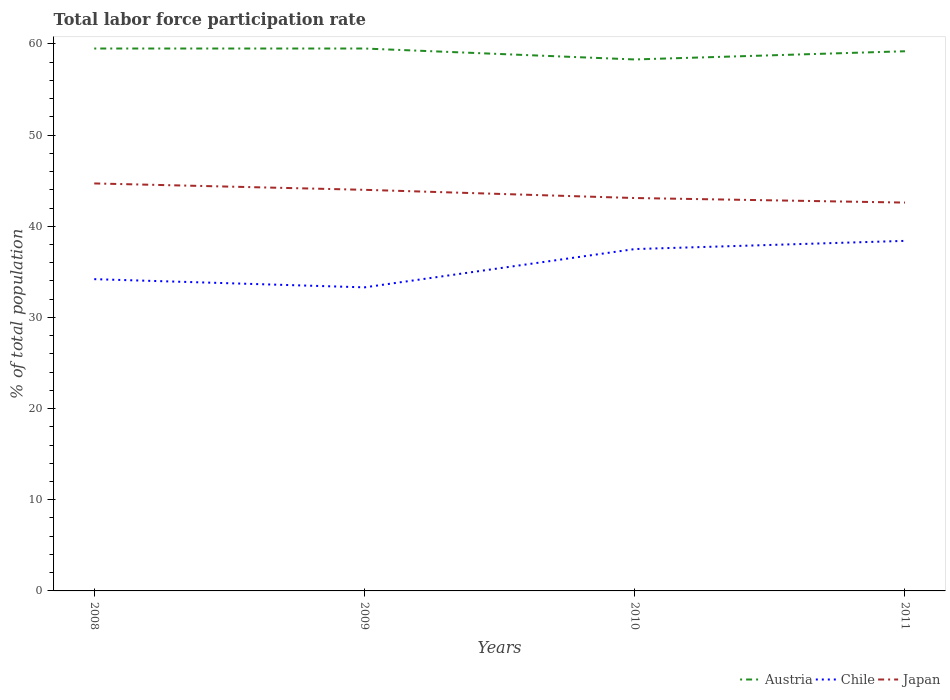How many different coloured lines are there?
Provide a short and direct response. 3. Across all years, what is the maximum total labor force participation rate in Austria?
Provide a short and direct response. 58.3. In which year was the total labor force participation rate in Japan maximum?
Offer a very short reply. 2011. What is the total total labor force participation rate in Austria in the graph?
Provide a short and direct response. 0.3. What is the difference between the highest and the second highest total labor force participation rate in Japan?
Ensure brevity in your answer.  2.1. How many lines are there?
Your answer should be compact. 3. What is the difference between two consecutive major ticks on the Y-axis?
Ensure brevity in your answer.  10. Does the graph contain grids?
Your answer should be very brief. No. Where does the legend appear in the graph?
Give a very brief answer. Bottom right. How many legend labels are there?
Offer a terse response. 3. What is the title of the graph?
Your answer should be very brief. Total labor force participation rate. Does "Syrian Arab Republic" appear as one of the legend labels in the graph?
Give a very brief answer. No. What is the label or title of the Y-axis?
Make the answer very short. % of total population. What is the % of total population of Austria in 2008?
Keep it short and to the point. 59.5. What is the % of total population in Chile in 2008?
Your answer should be very brief. 34.2. What is the % of total population of Japan in 2008?
Provide a succinct answer. 44.7. What is the % of total population in Austria in 2009?
Make the answer very short. 59.5. What is the % of total population of Chile in 2009?
Provide a succinct answer. 33.3. What is the % of total population in Austria in 2010?
Give a very brief answer. 58.3. What is the % of total population of Chile in 2010?
Offer a very short reply. 37.5. What is the % of total population in Japan in 2010?
Offer a very short reply. 43.1. What is the % of total population of Austria in 2011?
Your answer should be compact. 59.2. What is the % of total population of Chile in 2011?
Your answer should be compact. 38.4. What is the % of total population of Japan in 2011?
Make the answer very short. 42.6. Across all years, what is the maximum % of total population of Austria?
Provide a succinct answer. 59.5. Across all years, what is the maximum % of total population in Chile?
Keep it short and to the point. 38.4. Across all years, what is the maximum % of total population of Japan?
Keep it short and to the point. 44.7. Across all years, what is the minimum % of total population in Austria?
Your answer should be very brief. 58.3. Across all years, what is the minimum % of total population of Chile?
Offer a terse response. 33.3. Across all years, what is the minimum % of total population of Japan?
Give a very brief answer. 42.6. What is the total % of total population of Austria in the graph?
Give a very brief answer. 236.5. What is the total % of total population of Chile in the graph?
Give a very brief answer. 143.4. What is the total % of total population in Japan in the graph?
Make the answer very short. 174.4. What is the difference between the % of total population of Chile in 2008 and that in 2010?
Ensure brevity in your answer.  -3.3. What is the difference between the % of total population of Japan in 2008 and that in 2010?
Your answer should be very brief. 1.6. What is the difference between the % of total population of Austria in 2009 and that in 2010?
Offer a terse response. 1.2. What is the difference between the % of total population of Chile in 2009 and that in 2010?
Provide a short and direct response. -4.2. What is the difference between the % of total population in Japan in 2009 and that in 2010?
Offer a terse response. 0.9. What is the difference between the % of total population of Austria in 2009 and that in 2011?
Provide a short and direct response. 0.3. What is the difference between the % of total population in Chile in 2009 and that in 2011?
Provide a short and direct response. -5.1. What is the difference between the % of total population of Austria in 2010 and that in 2011?
Provide a short and direct response. -0.9. What is the difference between the % of total population of Japan in 2010 and that in 2011?
Provide a succinct answer. 0.5. What is the difference between the % of total population of Austria in 2008 and the % of total population of Chile in 2009?
Provide a succinct answer. 26.2. What is the difference between the % of total population of Chile in 2008 and the % of total population of Japan in 2009?
Your answer should be compact. -9.8. What is the difference between the % of total population in Chile in 2008 and the % of total population in Japan in 2010?
Make the answer very short. -8.9. What is the difference between the % of total population of Austria in 2008 and the % of total population of Chile in 2011?
Your answer should be very brief. 21.1. What is the difference between the % of total population of Austria in 2009 and the % of total population of Japan in 2010?
Provide a short and direct response. 16.4. What is the difference between the % of total population in Austria in 2009 and the % of total population in Chile in 2011?
Give a very brief answer. 21.1. What is the difference between the % of total population of Austria in 2009 and the % of total population of Japan in 2011?
Offer a very short reply. 16.9. What is the difference between the % of total population of Chile in 2009 and the % of total population of Japan in 2011?
Your response must be concise. -9.3. What is the difference between the % of total population of Austria in 2010 and the % of total population of Chile in 2011?
Make the answer very short. 19.9. What is the difference between the % of total population in Chile in 2010 and the % of total population in Japan in 2011?
Your answer should be compact. -5.1. What is the average % of total population of Austria per year?
Ensure brevity in your answer.  59.12. What is the average % of total population of Chile per year?
Keep it short and to the point. 35.85. What is the average % of total population in Japan per year?
Offer a very short reply. 43.6. In the year 2008, what is the difference between the % of total population of Austria and % of total population of Chile?
Give a very brief answer. 25.3. In the year 2008, what is the difference between the % of total population of Chile and % of total population of Japan?
Your answer should be very brief. -10.5. In the year 2009, what is the difference between the % of total population of Austria and % of total population of Chile?
Your answer should be very brief. 26.2. In the year 2009, what is the difference between the % of total population in Chile and % of total population in Japan?
Keep it short and to the point. -10.7. In the year 2010, what is the difference between the % of total population in Austria and % of total population in Chile?
Offer a very short reply. 20.8. In the year 2010, what is the difference between the % of total population in Chile and % of total population in Japan?
Keep it short and to the point. -5.6. In the year 2011, what is the difference between the % of total population of Austria and % of total population of Chile?
Give a very brief answer. 20.8. In the year 2011, what is the difference between the % of total population of Austria and % of total population of Japan?
Your answer should be compact. 16.6. What is the ratio of the % of total population of Chile in 2008 to that in 2009?
Your response must be concise. 1.03. What is the ratio of the % of total population of Japan in 2008 to that in 2009?
Provide a short and direct response. 1.02. What is the ratio of the % of total population of Austria in 2008 to that in 2010?
Offer a terse response. 1.02. What is the ratio of the % of total population in Chile in 2008 to that in 2010?
Give a very brief answer. 0.91. What is the ratio of the % of total population of Japan in 2008 to that in 2010?
Your answer should be compact. 1.04. What is the ratio of the % of total population of Chile in 2008 to that in 2011?
Offer a terse response. 0.89. What is the ratio of the % of total population in Japan in 2008 to that in 2011?
Ensure brevity in your answer.  1.05. What is the ratio of the % of total population in Austria in 2009 to that in 2010?
Your answer should be very brief. 1.02. What is the ratio of the % of total population of Chile in 2009 to that in 2010?
Your answer should be very brief. 0.89. What is the ratio of the % of total population in Japan in 2009 to that in 2010?
Your answer should be very brief. 1.02. What is the ratio of the % of total population in Chile in 2009 to that in 2011?
Offer a terse response. 0.87. What is the ratio of the % of total population of Japan in 2009 to that in 2011?
Give a very brief answer. 1.03. What is the ratio of the % of total population in Chile in 2010 to that in 2011?
Offer a very short reply. 0.98. What is the ratio of the % of total population of Japan in 2010 to that in 2011?
Your answer should be very brief. 1.01. What is the difference between the highest and the second highest % of total population of Chile?
Ensure brevity in your answer.  0.9. What is the difference between the highest and the second highest % of total population of Japan?
Offer a terse response. 0.7. 